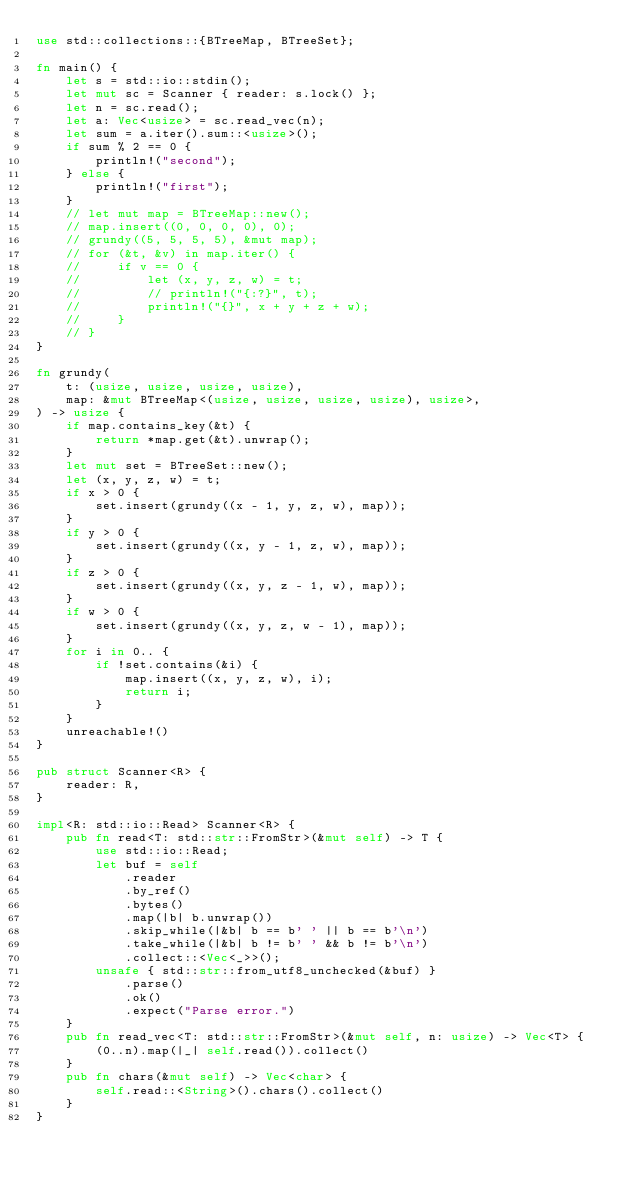Convert code to text. <code><loc_0><loc_0><loc_500><loc_500><_Rust_>use std::collections::{BTreeMap, BTreeSet};

fn main() {
    let s = std::io::stdin();
    let mut sc = Scanner { reader: s.lock() };
    let n = sc.read();
    let a: Vec<usize> = sc.read_vec(n);
    let sum = a.iter().sum::<usize>();
    if sum % 2 == 0 {
        println!("second");
    } else {
        println!("first");
    }
    // let mut map = BTreeMap::new();
    // map.insert((0, 0, 0, 0), 0);
    // grundy((5, 5, 5, 5), &mut map);
    // for (&t, &v) in map.iter() {
    //     if v == 0 {
    //         let (x, y, z, w) = t;
    //         // println!("{:?}", t);
    //         println!("{}", x + y + z + w);
    //     }
    // }
}

fn grundy(
    t: (usize, usize, usize, usize),
    map: &mut BTreeMap<(usize, usize, usize, usize), usize>,
) -> usize {
    if map.contains_key(&t) {
        return *map.get(&t).unwrap();
    }
    let mut set = BTreeSet::new();
    let (x, y, z, w) = t;
    if x > 0 {
        set.insert(grundy((x - 1, y, z, w), map));
    }
    if y > 0 {
        set.insert(grundy((x, y - 1, z, w), map));
    }
    if z > 0 {
        set.insert(grundy((x, y, z - 1, w), map));
    }
    if w > 0 {
        set.insert(grundy((x, y, z, w - 1), map));
    }
    for i in 0.. {
        if !set.contains(&i) {
            map.insert((x, y, z, w), i);
            return i;
        }
    }
    unreachable!()
}

pub struct Scanner<R> {
    reader: R,
}

impl<R: std::io::Read> Scanner<R> {
    pub fn read<T: std::str::FromStr>(&mut self) -> T {
        use std::io::Read;
        let buf = self
            .reader
            .by_ref()
            .bytes()
            .map(|b| b.unwrap())
            .skip_while(|&b| b == b' ' || b == b'\n')
            .take_while(|&b| b != b' ' && b != b'\n')
            .collect::<Vec<_>>();
        unsafe { std::str::from_utf8_unchecked(&buf) }
            .parse()
            .ok()
            .expect("Parse error.")
    }
    pub fn read_vec<T: std::str::FromStr>(&mut self, n: usize) -> Vec<T> {
        (0..n).map(|_| self.read()).collect()
    }
    pub fn chars(&mut self) -> Vec<char> {
        self.read::<String>().chars().collect()
    }
}
</code> 